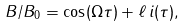<formula> <loc_0><loc_0><loc_500><loc_500>B / B _ { 0 } = \cos ( \Omega \tau ) + \ell \, i ( \tau ) ,</formula> 